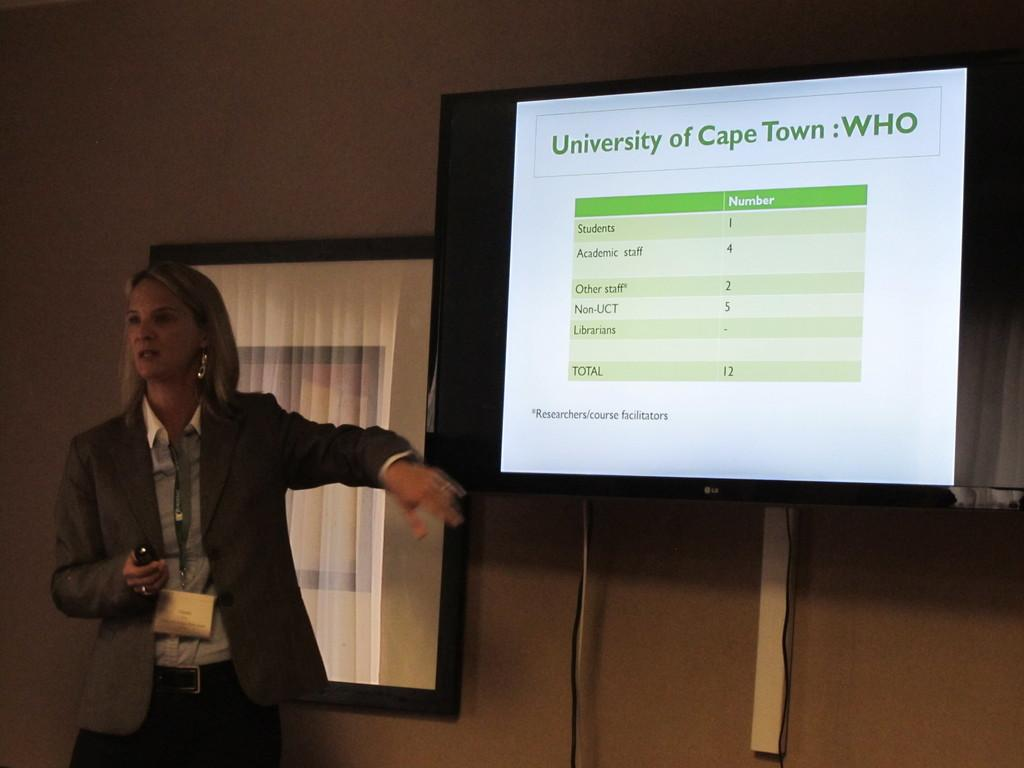Who is present in the image? There is a woman in the image. What is the woman wearing? The woman is wearing a blazer. What is the woman holding in her hand? The woman is holding a remote in her hand. What can be seen on the right side of the image? There is a screen attached to the wall on the right side of the image. What is displayed on the screen? The screen has a window on it. What type of gold can be seen in the woman's hand? There is no gold present in the image; the woman is holding a remote. 